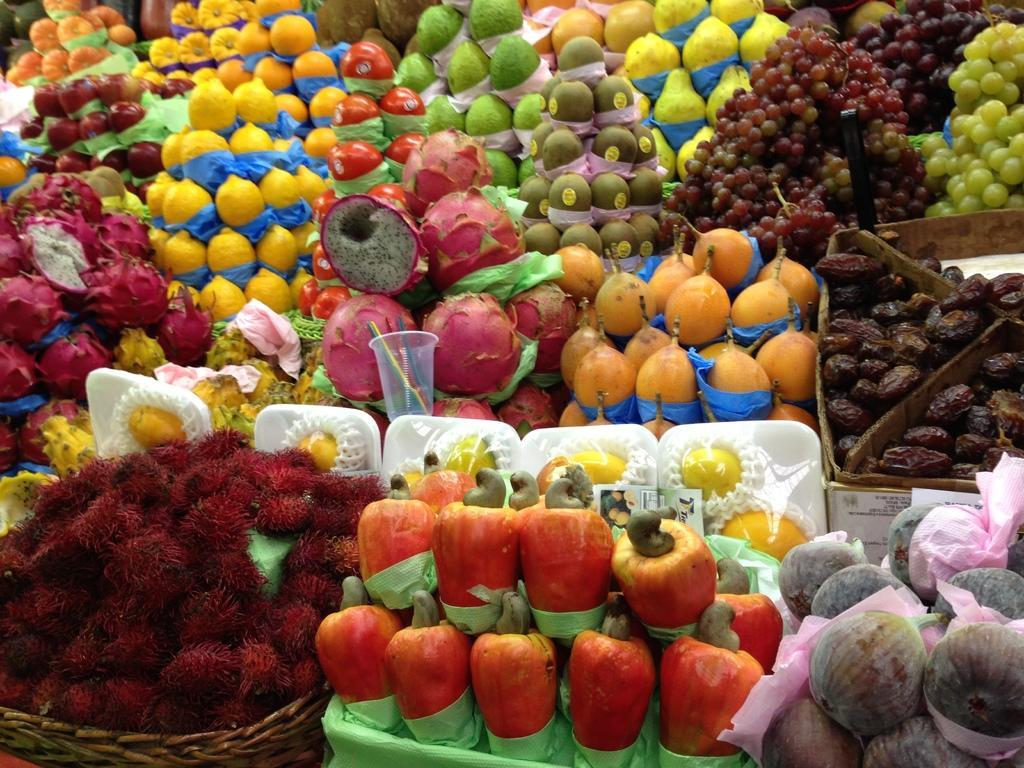Please provide a concise description of this image. In the given picture, I can see a numerous fruits. 